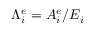Convert formula to latex. <formula><loc_0><loc_0><loc_500><loc_500>{ \Lambda } _ { i } ^ { e } = A _ { i } ^ { e } / E _ { i }</formula> 